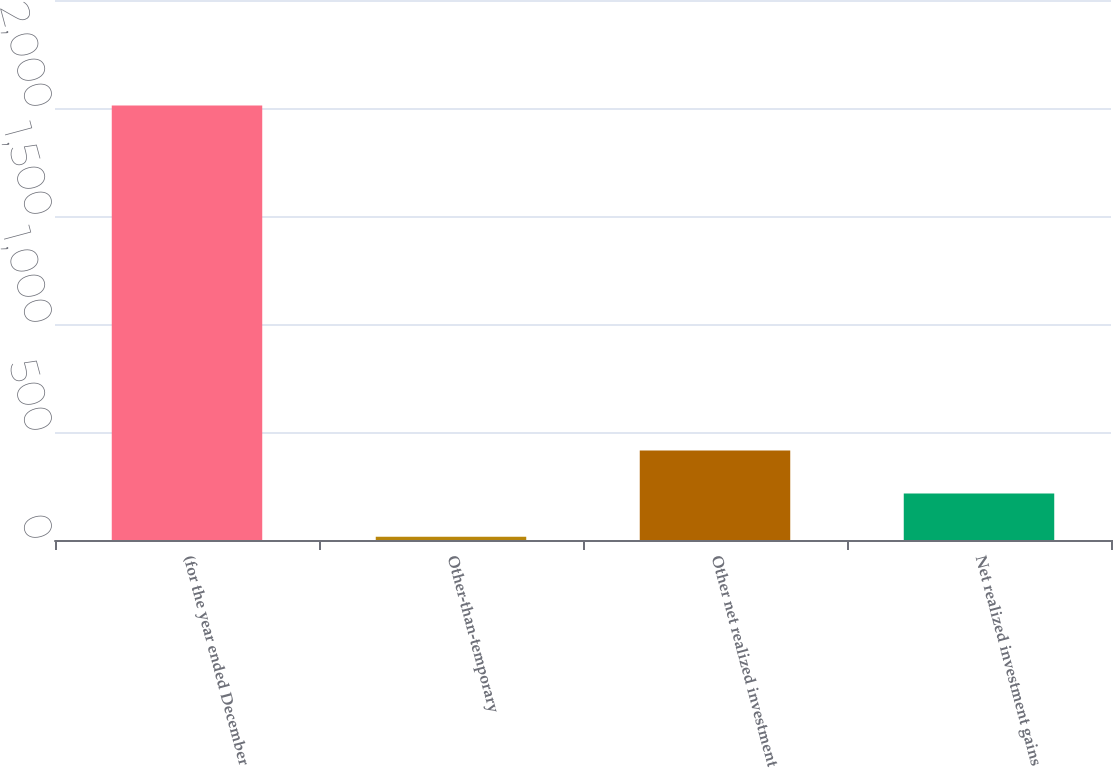<chart> <loc_0><loc_0><loc_500><loc_500><bar_chart><fcel>(for the year ended December<fcel>Other-than-temporary<fcel>Other net realized investment<fcel>Net realized investment gains<nl><fcel>2012<fcel>15<fcel>414.4<fcel>214.7<nl></chart> 